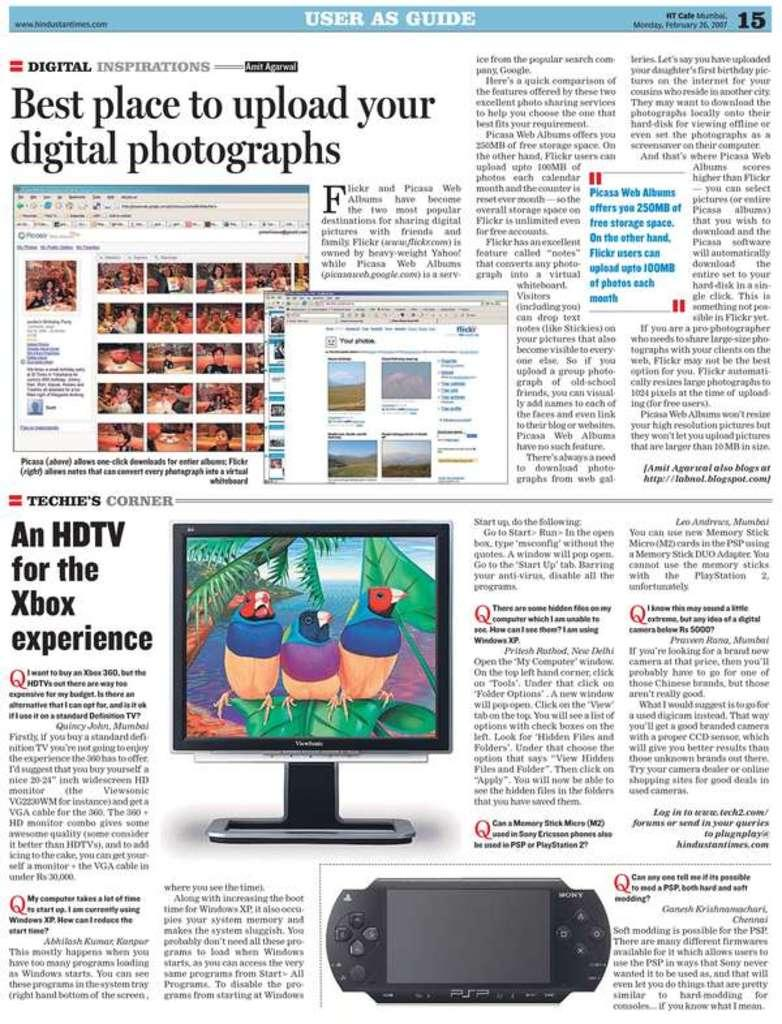What type of content is featured in the newspaper column in the image? The content of the newspaper column in the image is not specified, but it is a part of a newspaper. What electronic device is present in the image? There is a monitor in the image. What gaming console is visible in the image? There is a PlayStation in the image. What type of text can be seen in the image? There is text in the image, including the newspaper column and dialogue boxes. What are the dialogue boxes used for in the image? The dialogue boxes in the image are likely used for displaying text or information related to the content on the monitor or PlayStation. Can you see a toad wearing a collar in the image? No, there is no toad or collar present in the image. 